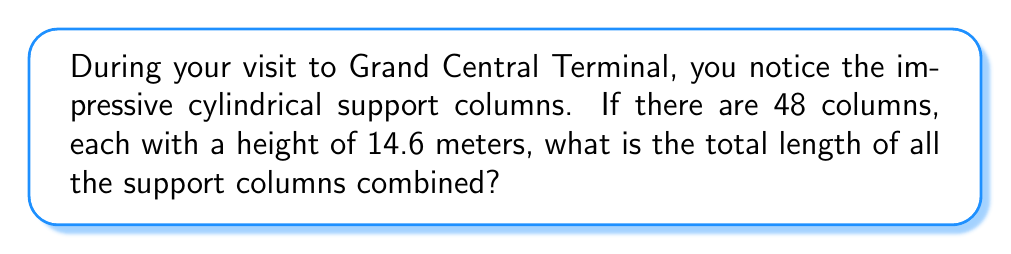Provide a solution to this math problem. To solve this problem, we need to follow these steps:

1. Identify the given information:
   - Number of columns: 48
   - Height of each column: 14.6 meters

2. Calculate the total length by multiplying the number of columns by the height of each column:
   
   $$ \text{Total length} = \text{Number of columns} \times \text{Height of each column} $$
   $$ \text{Total length} = 48 \times 14.6 \text{ meters} $$
   $$ \text{Total length} = 700.8 \text{ meters} $$

3. Round the result to a whole number for simplicity:
   $$ \text{Total length} \approx 701 \text{ meters} $$

This calculation gives us the combined length of all cylindrical support columns in Grand Central Terminal.
Answer: 701 meters 